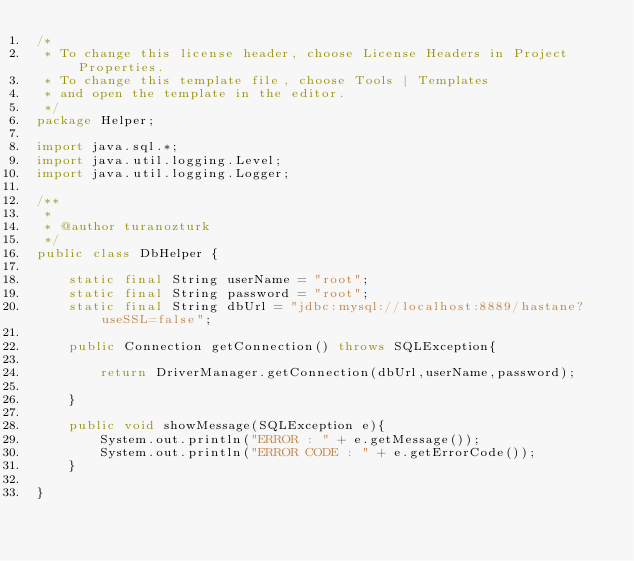<code> <loc_0><loc_0><loc_500><loc_500><_Java_>/*
 * To change this license header, choose License Headers in Project Properties.
 * To change this template file, choose Tools | Templates
 * and open the template in the editor.
 */
package Helper;

import java.sql.*;
import java.util.logging.Level;
import java.util.logging.Logger;

/**
 *
 * @author turanozturk
 */
public class DbHelper {
    
    static final String userName = "root";
    static final String password = "root";
    static final String dbUrl = "jdbc:mysql://localhost:8889/hastane?useSSL=false";
    
    public Connection getConnection() throws SQLException{
    
        return DriverManager.getConnection(dbUrl,userName,password);
        
    }
    
    public void showMessage(SQLException e){
        System.out.println("ERROR : " + e.getMessage());
        System.out.println("ERROR CODE : " + e.getErrorCode());
    }
 
}
</code> 